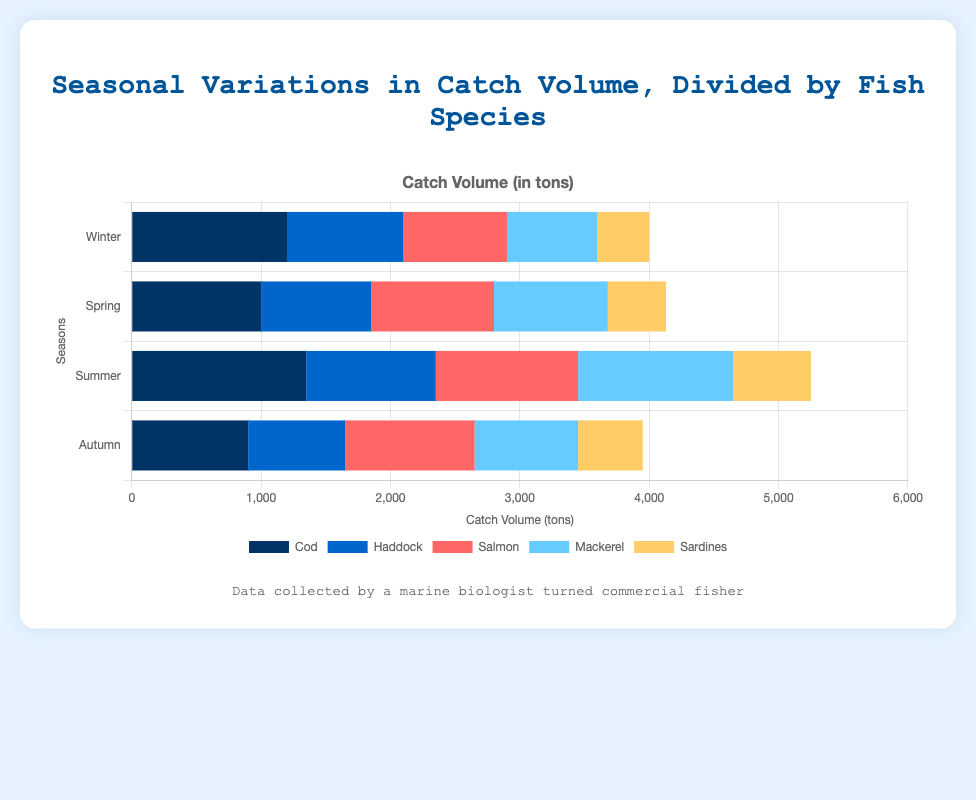Which fish species had the highest catch volume in Summer? Look at the Summer section of the bar chart and compare the lengths of the bars for each fish species. Mackerel has the longest bar in Summer, indicating the highest catch volume.
Answer: Mackerel What is the difference in the catch volume of Cod between Winter and Autumn? Find the values for Cod in both Winter and Autumn from the chart. In Winter, Cod's catch volume is 1200 tons and in Autumn it is 900 tons. The difference is 1200 - 900 = 300 tons.
Answer: 300 tons Which season had the lowest catch volume for Salmon? Compare the lengths of the Salmon bars across all seasons. The Winter bar is the shortest for Salmon, indicating the lowest catch volume.
Answer: Winter What is the total catch volume for all fish species in Spring? Sum up the values of all fish species in Spring. Cod: 1000, Haddock: 850, Salmon: 950, Mackerel: 880, Sardines: 450. The total is 1000 + 850 + 950 + 880 + 450 = 4130 tons.
Answer: 4130 tons How does the catch volume of Mackerel in Winter compare to that in Summer? Compare the lengths of the Mackerel bars in Winter and Summer. The bar in Summer is much longer than in Winter, indicating a higher catch volume in Summer.
Answer: Higher in Summer What's the combined catch volume of Haddock and Sardines in Autumn? Add the values for Haddock and Sardines in Autumn. Haddock is 750 tons and Sardines are 500 tons. The combined catch volume is 750 + 500 = 1250 tons.
Answer: 1250 tons In which season is the total catch volume for Cod and Salmon equal? Look for the season where the sum of Cod and Salmon's catch volumes is the same. In Autumn, Cod: 900 and Salmon: 1000, total is 900 + 1000 = 1900; in Summer, Cod: 1350 and Salmon: 1100, total is 1350 + 1100 = 2450; in Spring, Cod: 1000 and Salmon: 950, total is 1000 + 950 = 1950. In Winter, Cod: 1200 and Salmon: 800, total is 1200 + 800 = 2000. None of the seasons have equal totals for Cod and Salmon.
Answer: None Which fish species showed the most consistent catch volume across all seasons? Identify the species whose bars have similar lengths across all seasons. Haddock's bars have the most similar lengths across Winter, Spring, Summer, and Autumn.
Answer: Haddock 